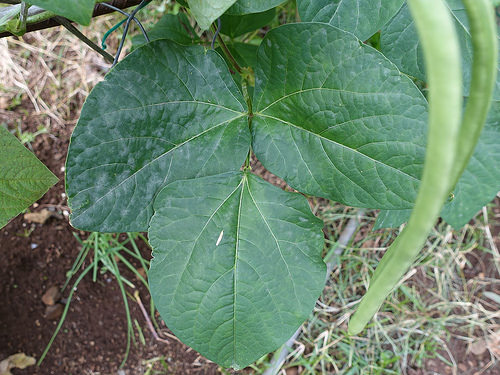<image>
Can you confirm if the plant is above the soil? Yes. The plant is positioned above the soil in the vertical space, higher up in the scene. 